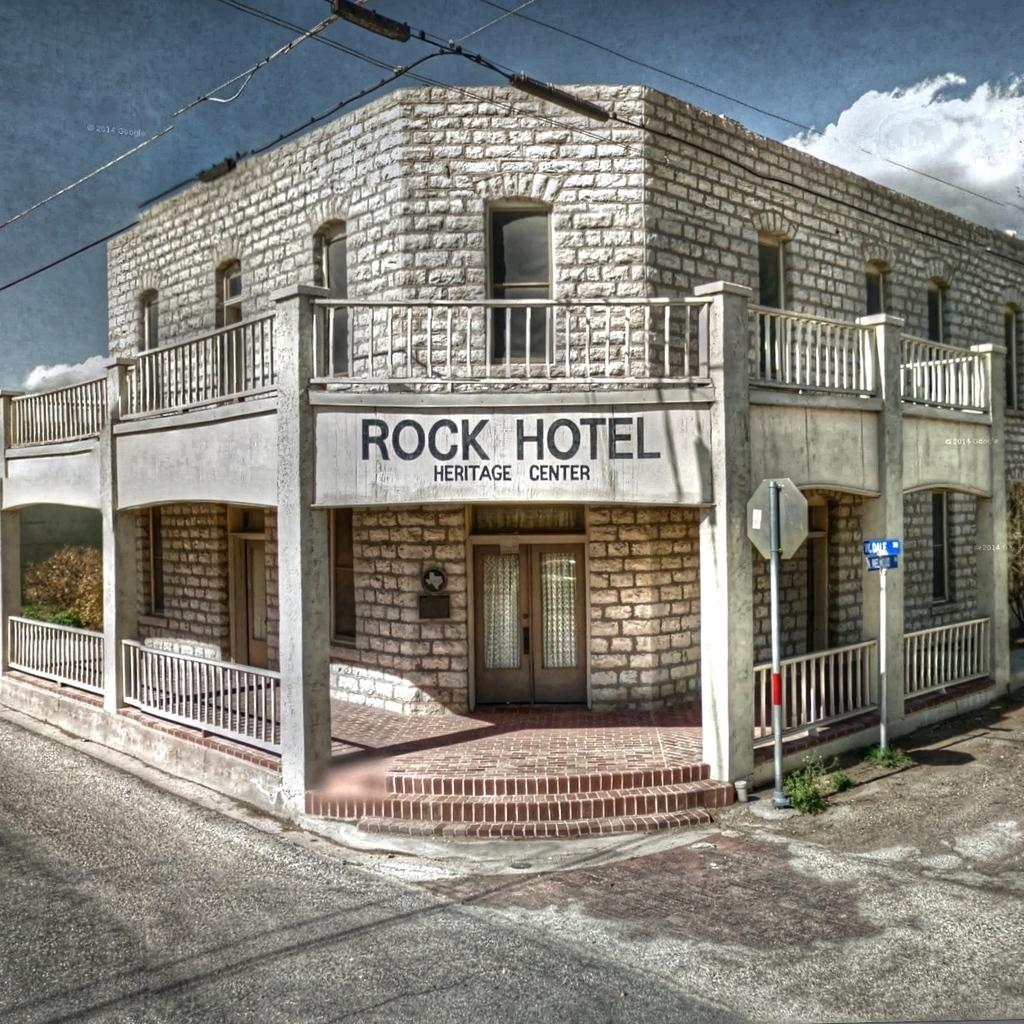What is the main feature of the image? There is a road in the image. What can be seen in the distance behind the road? There is a building in the background of the image. What else is present in the background of the image? There are poles and wires in the background of the image. What part of the natural environment is visible in the image? The sky is visible in the background of the image. Can you see any visible veins in the image? There are no visible veins in the image, as it features a road, a building, poles, wires, and the sky. What type of badge is being worn by the person in the image? There is no person present in the image, so it is not possible to determine if anyone is wearing a badge. 